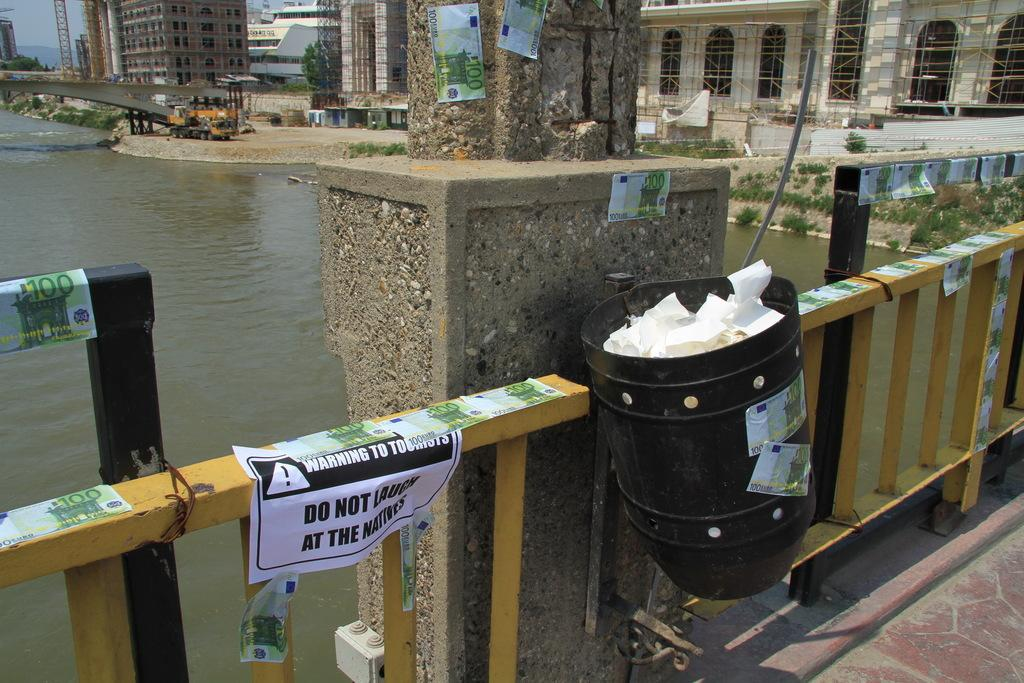<image>
Describe the image concisely. Sign on some rails that says "Do not laugh at the natives". 